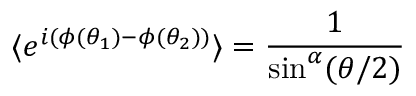Convert formula to latex. <formula><loc_0><loc_0><loc_500><loc_500>\langle e ^ { i ( \phi ( \theta _ { 1 } ) - \phi ( \theta _ { 2 } ) ) } \rangle = \frac { 1 } \sin ^ { \alpha } ( \theta / 2 ) }</formula> 